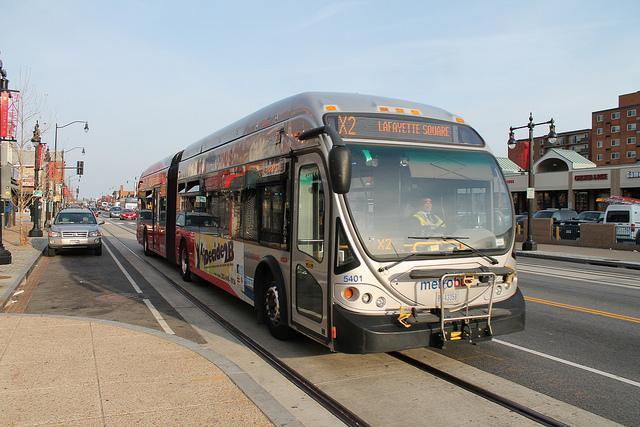How many clouds are in the picture?
Give a very brief answer. 0. How many brown horses are jumping in this photo?
Give a very brief answer. 0. 